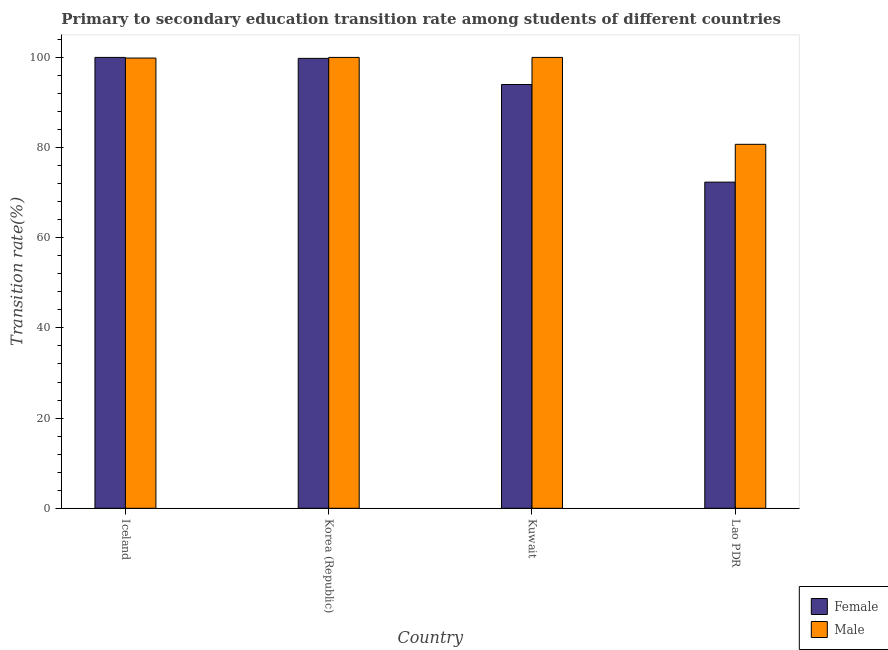How many different coloured bars are there?
Keep it short and to the point. 2. Are the number of bars per tick equal to the number of legend labels?
Your answer should be very brief. Yes. Are the number of bars on each tick of the X-axis equal?
Offer a very short reply. Yes. How many bars are there on the 1st tick from the left?
Offer a very short reply. 2. How many bars are there on the 3rd tick from the right?
Make the answer very short. 2. What is the label of the 2nd group of bars from the left?
Provide a succinct answer. Korea (Republic). In how many cases, is the number of bars for a given country not equal to the number of legend labels?
Your answer should be compact. 0. Across all countries, what is the minimum transition rate among male students?
Your response must be concise. 80.72. In which country was the transition rate among male students maximum?
Give a very brief answer. Korea (Republic). In which country was the transition rate among female students minimum?
Provide a short and direct response. Lao PDR. What is the total transition rate among male students in the graph?
Provide a short and direct response. 380.58. What is the difference between the transition rate among female students in Iceland and that in Lao PDR?
Your response must be concise. 27.66. What is the difference between the transition rate among female students in Lao PDR and the transition rate among male students in Korea (Republic)?
Provide a short and direct response. -27.66. What is the average transition rate among female students per country?
Offer a terse response. 91.53. What is the difference between the transition rate among male students and transition rate among female students in Iceland?
Ensure brevity in your answer.  -0.14. In how many countries, is the transition rate among female students greater than 24 %?
Your answer should be compact. 4. What is the ratio of the transition rate among female students in Kuwait to that in Lao PDR?
Provide a succinct answer. 1.3. What is the difference between the highest and the second highest transition rate among male students?
Provide a short and direct response. 0. What is the difference between the highest and the lowest transition rate among male students?
Provide a succinct answer. 19.28. In how many countries, is the transition rate among male students greater than the average transition rate among male students taken over all countries?
Provide a short and direct response. 3. How many bars are there?
Make the answer very short. 8. How many countries are there in the graph?
Keep it short and to the point. 4. Does the graph contain grids?
Give a very brief answer. No. How many legend labels are there?
Offer a terse response. 2. What is the title of the graph?
Provide a short and direct response. Primary to secondary education transition rate among students of different countries. What is the label or title of the Y-axis?
Ensure brevity in your answer.  Transition rate(%). What is the Transition rate(%) of Female in Iceland?
Provide a short and direct response. 100. What is the Transition rate(%) in Male in Iceland?
Ensure brevity in your answer.  99.86. What is the Transition rate(%) in Female in Korea (Republic)?
Your response must be concise. 99.79. What is the Transition rate(%) in Male in Korea (Republic)?
Ensure brevity in your answer.  100. What is the Transition rate(%) of Female in Kuwait?
Keep it short and to the point. 93.99. What is the Transition rate(%) in Male in Kuwait?
Make the answer very short. 100. What is the Transition rate(%) in Female in Lao PDR?
Your answer should be very brief. 72.34. What is the Transition rate(%) in Male in Lao PDR?
Provide a succinct answer. 80.72. Across all countries, what is the maximum Transition rate(%) of Female?
Your response must be concise. 100. Across all countries, what is the minimum Transition rate(%) of Female?
Offer a terse response. 72.34. Across all countries, what is the minimum Transition rate(%) in Male?
Your answer should be compact. 80.72. What is the total Transition rate(%) of Female in the graph?
Provide a succinct answer. 366.12. What is the total Transition rate(%) of Male in the graph?
Give a very brief answer. 380.58. What is the difference between the Transition rate(%) in Female in Iceland and that in Korea (Republic)?
Your response must be concise. 0.21. What is the difference between the Transition rate(%) in Male in Iceland and that in Korea (Republic)?
Your answer should be compact. -0.14. What is the difference between the Transition rate(%) of Female in Iceland and that in Kuwait?
Your answer should be compact. 6.01. What is the difference between the Transition rate(%) in Male in Iceland and that in Kuwait?
Make the answer very short. -0.14. What is the difference between the Transition rate(%) of Female in Iceland and that in Lao PDR?
Keep it short and to the point. 27.66. What is the difference between the Transition rate(%) of Male in Iceland and that in Lao PDR?
Keep it short and to the point. 19.13. What is the difference between the Transition rate(%) in Female in Korea (Republic) and that in Kuwait?
Offer a very short reply. 5.8. What is the difference between the Transition rate(%) in Male in Korea (Republic) and that in Kuwait?
Provide a succinct answer. 0. What is the difference between the Transition rate(%) in Female in Korea (Republic) and that in Lao PDR?
Your answer should be very brief. 27.45. What is the difference between the Transition rate(%) in Male in Korea (Republic) and that in Lao PDR?
Your response must be concise. 19.28. What is the difference between the Transition rate(%) in Female in Kuwait and that in Lao PDR?
Keep it short and to the point. 21.65. What is the difference between the Transition rate(%) of Male in Kuwait and that in Lao PDR?
Keep it short and to the point. 19.28. What is the difference between the Transition rate(%) of Female in Iceland and the Transition rate(%) of Male in Korea (Republic)?
Offer a very short reply. 0. What is the difference between the Transition rate(%) of Female in Iceland and the Transition rate(%) of Male in Kuwait?
Offer a very short reply. 0. What is the difference between the Transition rate(%) of Female in Iceland and the Transition rate(%) of Male in Lao PDR?
Provide a short and direct response. 19.28. What is the difference between the Transition rate(%) in Female in Korea (Republic) and the Transition rate(%) in Male in Kuwait?
Provide a succinct answer. -0.21. What is the difference between the Transition rate(%) of Female in Korea (Republic) and the Transition rate(%) of Male in Lao PDR?
Offer a terse response. 19.06. What is the difference between the Transition rate(%) in Female in Kuwait and the Transition rate(%) in Male in Lao PDR?
Your answer should be very brief. 13.27. What is the average Transition rate(%) in Female per country?
Offer a terse response. 91.53. What is the average Transition rate(%) in Male per country?
Give a very brief answer. 95.15. What is the difference between the Transition rate(%) of Female and Transition rate(%) of Male in Iceland?
Offer a terse response. 0.14. What is the difference between the Transition rate(%) of Female and Transition rate(%) of Male in Korea (Republic)?
Offer a terse response. -0.21. What is the difference between the Transition rate(%) of Female and Transition rate(%) of Male in Kuwait?
Keep it short and to the point. -6.01. What is the difference between the Transition rate(%) of Female and Transition rate(%) of Male in Lao PDR?
Offer a very short reply. -8.39. What is the ratio of the Transition rate(%) in Female in Iceland to that in Korea (Republic)?
Your response must be concise. 1. What is the ratio of the Transition rate(%) in Female in Iceland to that in Kuwait?
Ensure brevity in your answer.  1.06. What is the ratio of the Transition rate(%) of Male in Iceland to that in Kuwait?
Offer a very short reply. 1. What is the ratio of the Transition rate(%) in Female in Iceland to that in Lao PDR?
Keep it short and to the point. 1.38. What is the ratio of the Transition rate(%) in Male in Iceland to that in Lao PDR?
Give a very brief answer. 1.24. What is the ratio of the Transition rate(%) in Female in Korea (Republic) to that in Kuwait?
Keep it short and to the point. 1.06. What is the ratio of the Transition rate(%) of Female in Korea (Republic) to that in Lao PDR?
Your response must be concise. 1.38. What is the ratio of the Transition rate(%) in Male in Korea (Republic) to that in Lao PDR?
Provide a short and direct response. 1.24. What is the ratio of the Transition rate(%) of Female in Kuwait to that in Lao PDR?
Give a very brief answer. 1.3. What is the ratio of the Transition rate(%) of Male in Kuwait to that in Lao PDR?
Provide a succinct answer. 1.24. What is the difference between the highest and the second highest Transition rate(%) in Female?
Make the answer very short. 0.21. What is the difference between the highest and the second highest Transition rate(%) in Male?
Offer a very short reply. 0. What is the difference between the highest and the lowest Transition rate(%) of Female?
Provide a short and direct response. 27.66. What is the difference between the highest and the lowest Transition rate(%) in Male?
Provide a short and direct response. 19.28. 